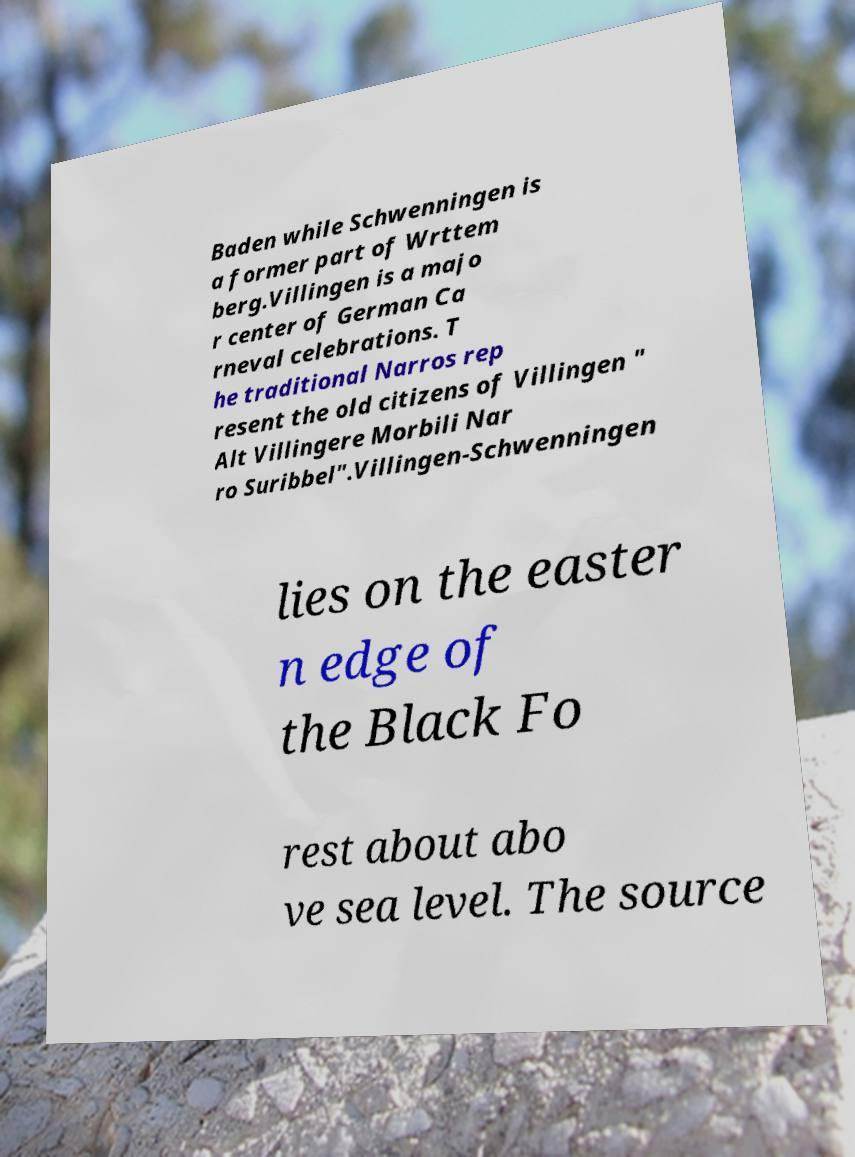Can you accurately transcribe the text from the provided image for me? Baden while Schwenningen is a former part of Wrttem berg.Villingen is a majo r center of German Ca rneval celebrations. T he traditional Narros rep resent the old citizens of Villingen " Alt Villingere Morbili Nar ro Suribbel".Villingen-Schwenningen lies on the easter n edge of the Black Fo rest about abo ve sea level. The source 